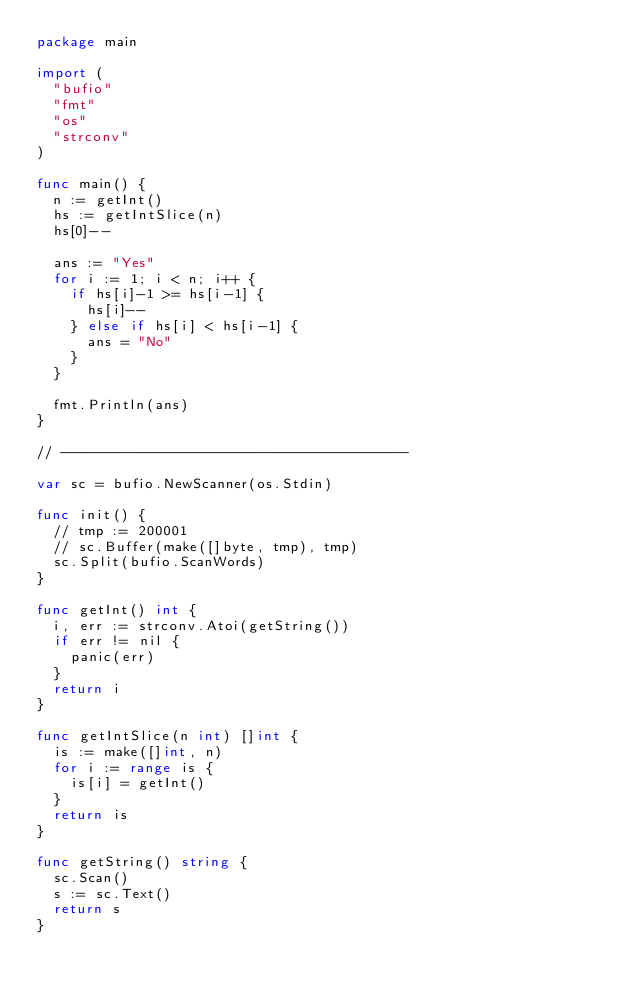<code> <loc_0><loc_0><loc_500><loc_500><_Go_>package main

import (
	"bufio"
	"fmt"
	"os"
	"strconv"
)

func main() {
	n := getInt()
	hs := getIntSlice(n)
	hs[0]--

	ans := "Yes"
	for i := 1; i < n; i++ {
		if hs[i]-1 >= hs[i-1] {
			hs[i]--
		} else if hs[i] < hs[i-1] {
			ans = "No"
		}
	}

	fmt.Println(ans)
}

// -----------------------------------------

var sc = bufio.NewScanner(os.Stdin)

func init() {
	// tmp := 200001
	// sc.Buffer(make([]byte, tmp), tmp)
	sc.Split(bufio.ScanWords)
}

func getInt() int {
	i, err := strconv.Atoi(getString())
	if err != nil {
		panic(err)
	}
	return i
}

func getIntSlice(n int) []int {
	is := make([]int, n)
	for i := range is {
		is[i] = getInt()
	}
	return is
}

func getString() string {
	sc.Scan()
	s := sc.Text()
	return s
}
</code> 